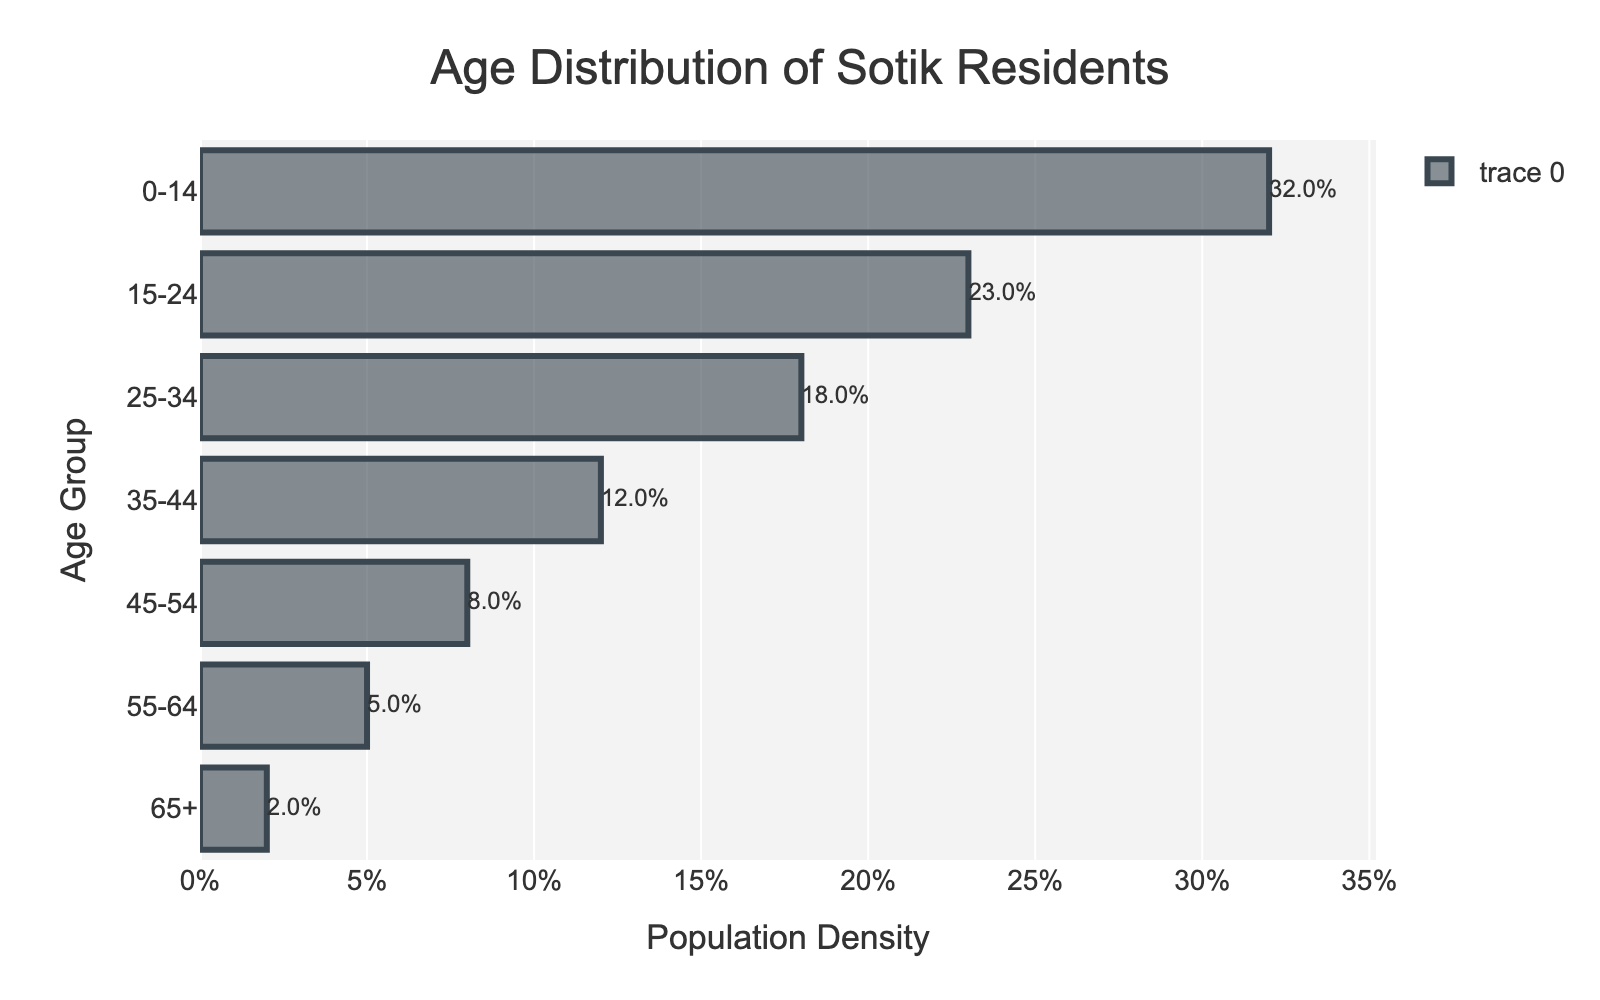What is the title of the plot? The title is mentioned at the top of the plot. It provides a summary of what the plot represents. The title is "Age Distribution of Sotik Residents"
Answer: Age Distribution of Sotik Residents Which age group has the highest population density? Check the bar with the greatest length. The group with the maximum bar is "0-14" with a density of 0.32 (32%).
Answer: 0-14 What is the population density percentage for the 25-34 age group? Locate the bar for the "25-34" age group and read the associated density value. The density for "25-34" is 0.18, which is equivalent to 18%.
Answer: 18% How many age groups are included in the plot? Count the number of bars shown on the y-axis. There are seven age groups in total.
Answer: 7 Which age group has the lowest population density? Identify the shortest bar. The group "65+" has the shortest bar with a density of 0.02 (2%).
Answer: 65+ What is the combined population density for the age groups "35-44" and "45-54"? Add the densities of "35-44" (0.12) and "45-54" (0.08). The total density is 0.12 + 0.08 = 0.20 or 20%.
Answer: 20% How does the population density of the "55-64" group compare to the "15-24" group? The "55-64" group has a density of 0.05, whereas the "15-24" group has a density of 0.23. Since 0.05 < 0.23, the "55-64" group has a lower density.
Answer: Lower Which age group has a population density that is twice that of the "65+" age group? The "65+" group has a density of 0.02. Doubling this, we get 0.02 * 2 = 0.04. The "55-64" group has a density of 0.05, which is closest to this but slightly more.
Answer: None What is the difference in population density between the "0-14" and "15-24" age groups? Subtract the density of "15-24" (0.23) from the density of "0-14" (0.32). The difference is 0.32 - 0.23 = 0.09 or 9%.
Answer: 9% How does the distribution of the younger population (0-34) compare to the older population (35-65+)? Sum the densities of the younger age groups: 0-14 (0.32), 15-24 (0.23), 25-34 (0.18) gives 0.32 + 0.23 + 0.18 = 0.73. Sum the densities of older groups: 35-44 (0.12), 45-54 (0.08), 55-64 (0.05), 65+ (0.02) gives 0.12 + 0.08 + 0.05 + 0.02 = 0.27. The younger population density (73%) is much higher than the older population density (27%).
Answer: Younger population has higher density 